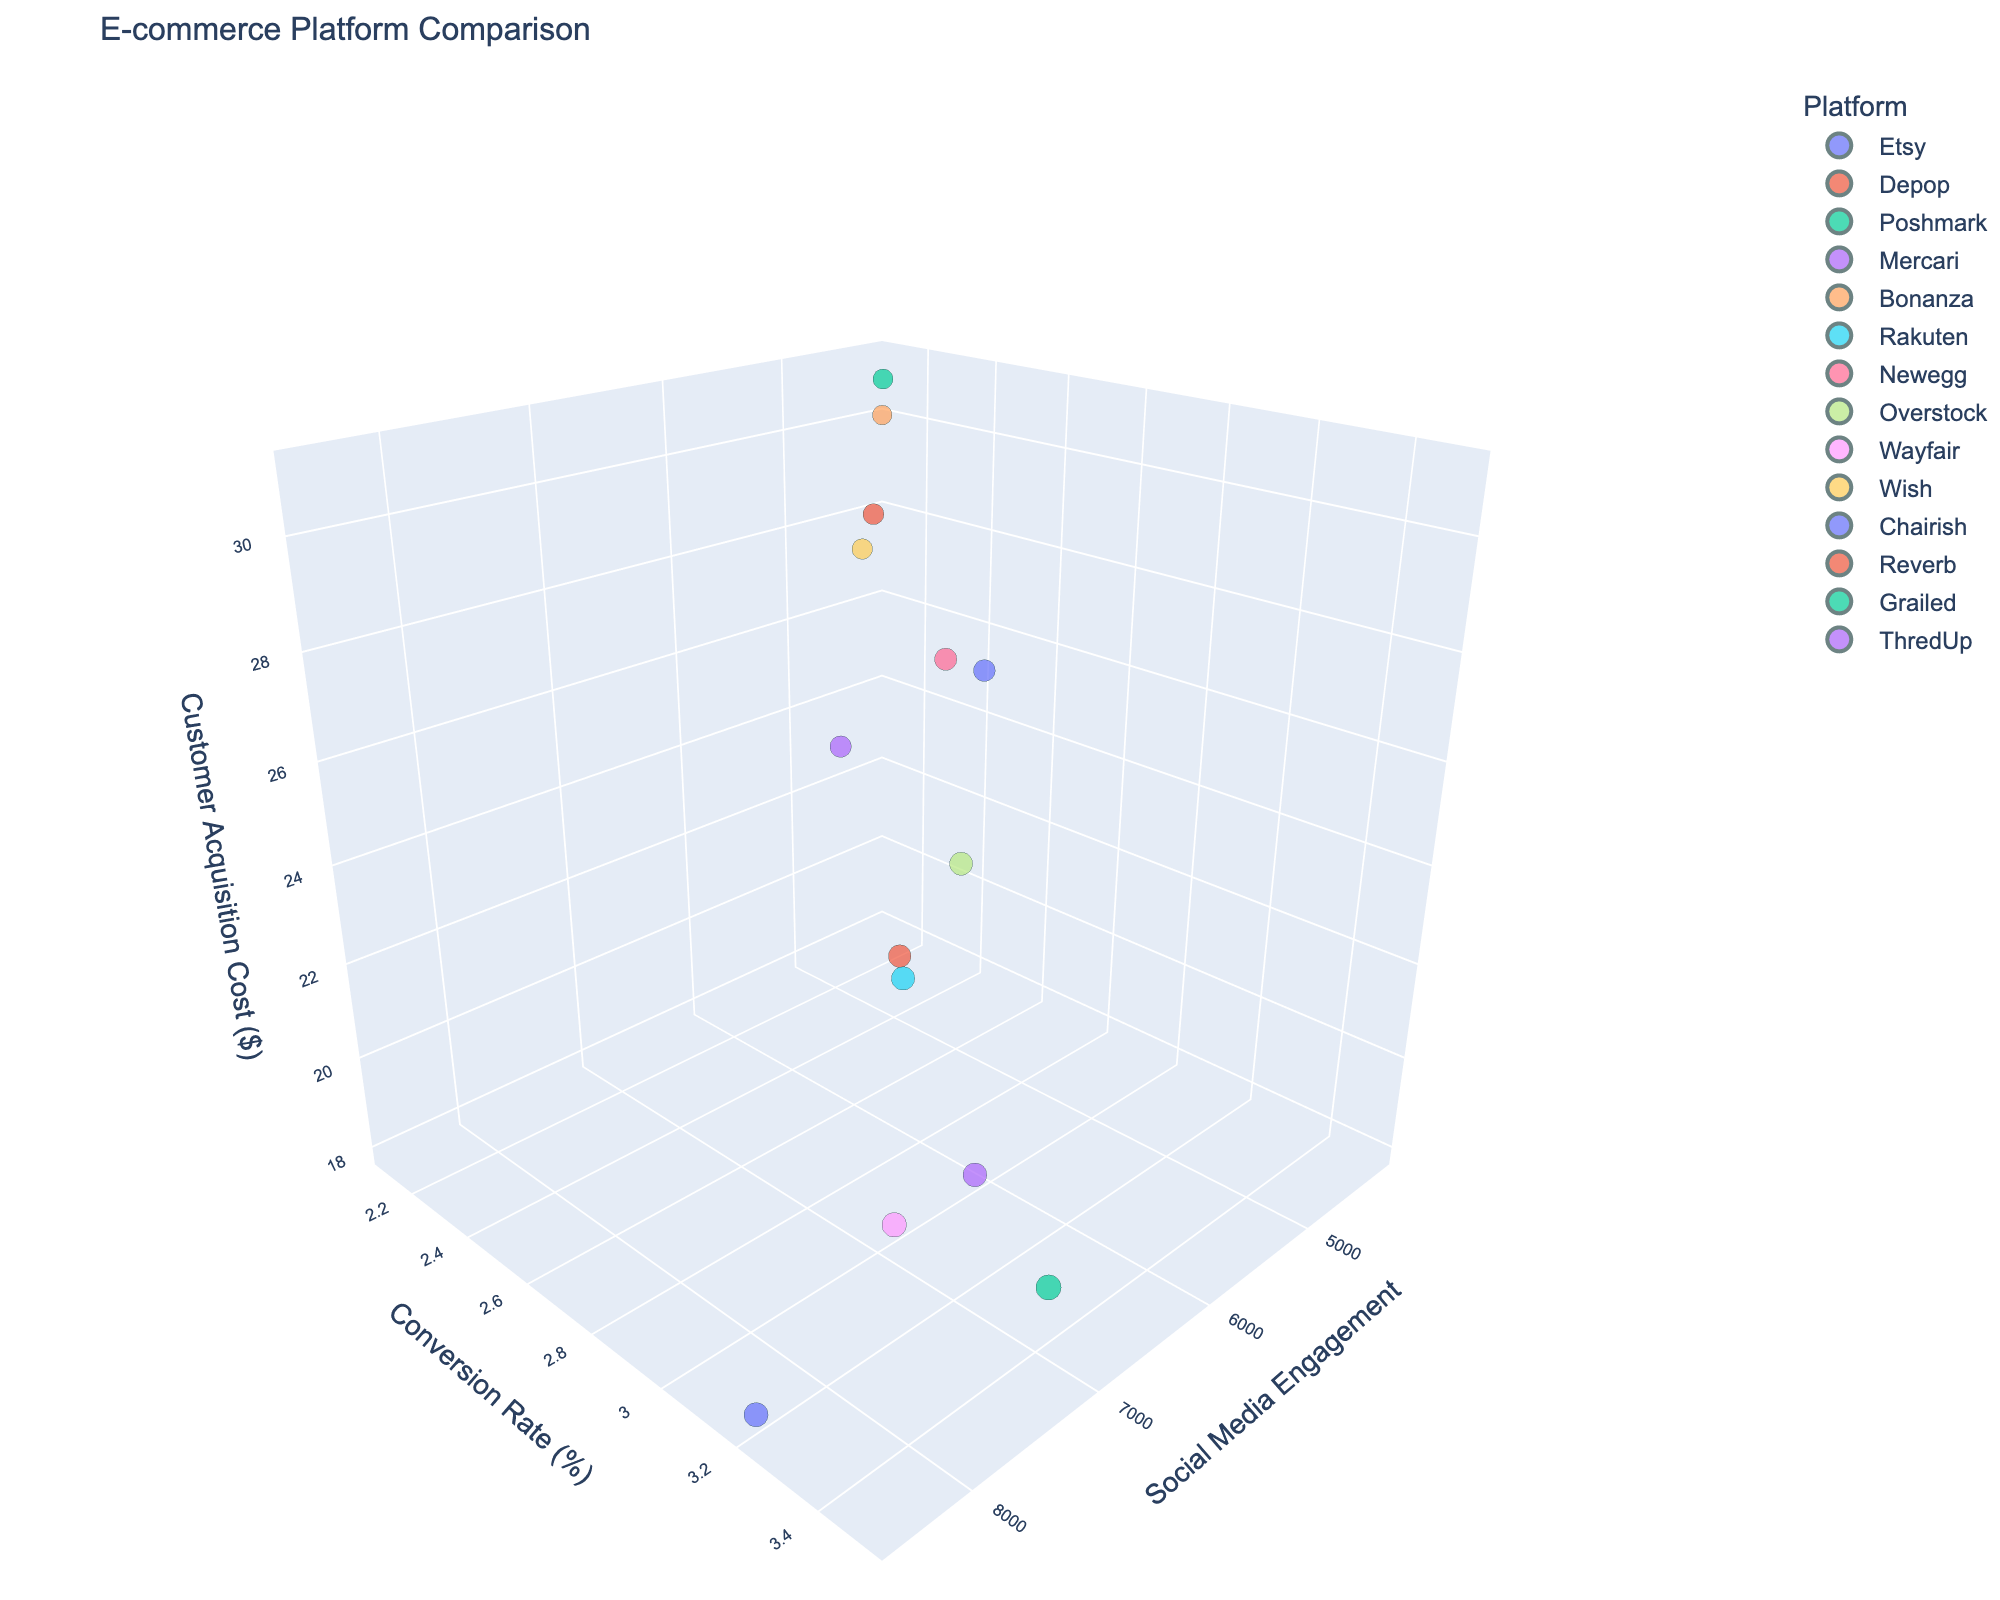What's the title of the plot? The title of the plot is typically located at the top of the plot and provides a summary of what the plot is about. Here, it should be visible at the top of the generated figure.
Answer: E-commerce Platform Comparison How many e-commerce platforms are compared in the plot? Each data point in the plot represents one platform, and they are labeled with the platform's name. By counting the labels, we can determine the number of platforms compared.
Answer: 14 Which e-commerce platform has the highest social media engagement? Look at the x-axis representing social media engagement and find the data point that is farthest to the right; this point will represent the platform with the highest engagement.
Answer: Etsy Which platform has the lowest customer acquisition cost? Look at the z-axis representing customer acquisition cost and find the data point that is lowest on this axis; this point will represent the platform with the lowest cost.
Answer: Etsy What is the conversion rate of Mercari, and how does it compare to Wayfair's conversion rate? Find the y-axis values for Mercari and Wayfair and compare them. Mercari's value can be found by locating its corresponding point on the y-axis and doing the same for Wayfair.
Answer: Mercari: 2.5%, Wayfair: 3.3% Which platform has the highest conversion rate and what is their customer acquisition cost? Identify the point with the highest value on the y-axis and read the corresponding z-axis value for customer acquisition cost. The highest y-axis value should indicate the platform with the highest conversion rate.
Answer: Poshmark, $20 Which platform has the lowest social media engagement and what is their conversion rate? Find the platform furthest to the left on the x-axis and check the corresponding y-axis value to get the conversion rate of that platform.
Answer: Bonanza, 2.1% Compare the social media engagement between Rakuten and Depop. Which has a higher engagement? Locate the points for Rakuten and Depop on the x-axis and compare their positions to see which one is further to the right.
Answer: Depop Is there a platform with a customer acquisition cost lower than $20 but with a social media engagement above 7000? Examine the z-axis values to find platforms with costs below $20, then check if their corresponding x-axis value is above 7000.
Answer: No What is the range of customer acquisition costs for the platforms listed? Identify the highest and lowest points on the z-axis and compute the difference between these values to find the range.
Answer: 31 - 18 = 13 